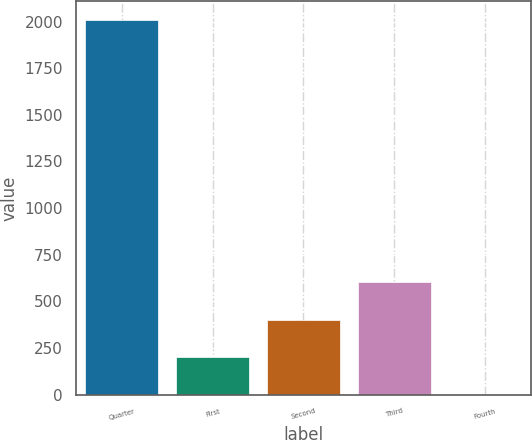<chart> <loc_0><loc_0><loc_500><loc_500><bar_chart><fcel>Quarter<fcel>First<fcel>Second<fcel>Third<fcel>Fourth<nl><fcel>2010<fcel>201.61<fcel>402.54<fcel>603.47<fcel>0.68<nl></chart> 